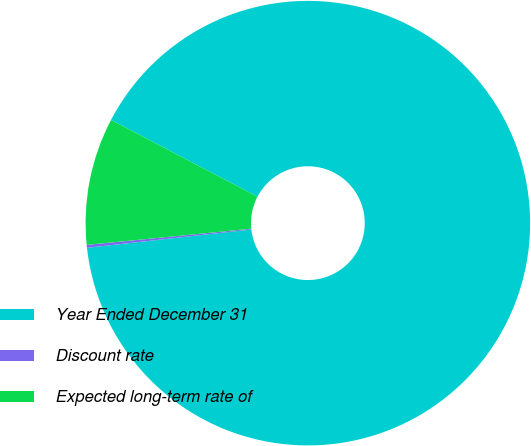Convert chart to OTSL. <chart><loc_0><loc_0><loc_500><loc_500><pie_chart><fcel>Year Ended December 31<fcel>Discount rate<fcel>Expected long-term rate of<nl><fcel>90.54%<fcel>0.21%<fcel>9.25%<nl></chart> 